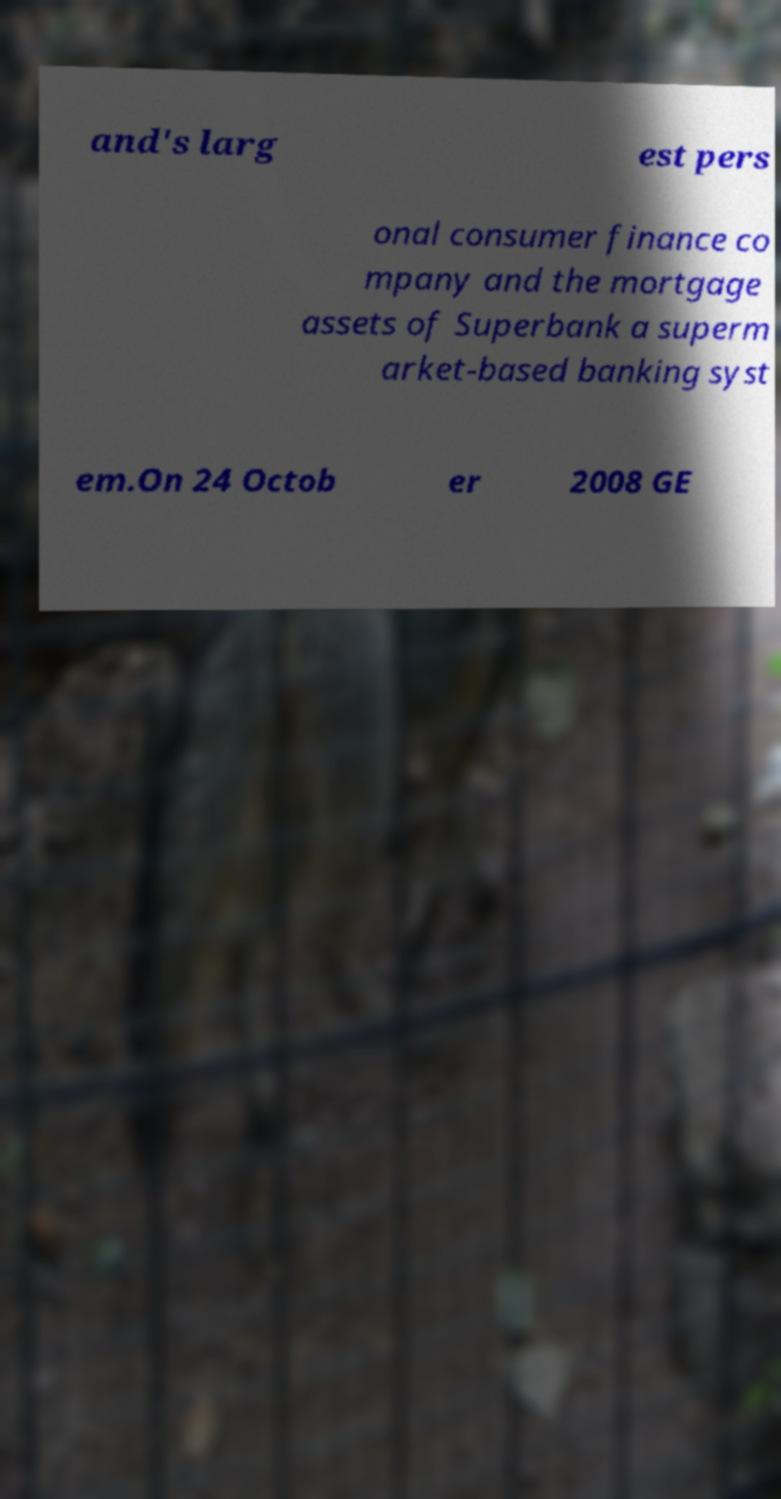There's text embedded in this image that I need extracted. Can you transcribe it verbatim? and's larg est pers onal consumer finance co mpany and the mortgage assets of Superbank a superm arket-based banking syst em.On 24 Octob er 2008 GE 